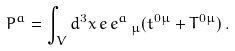Convert formula to latex. <formula><loc_0><loc_0><loc_500><loc_500>P ^ { a } = \int _ { V } d ^ { 3 } x \, e \, e ^ { a } \, _ { \mu } ( t ^ { 0 \mu } + T ^ { 0 \mu } ) \, .</formula> 